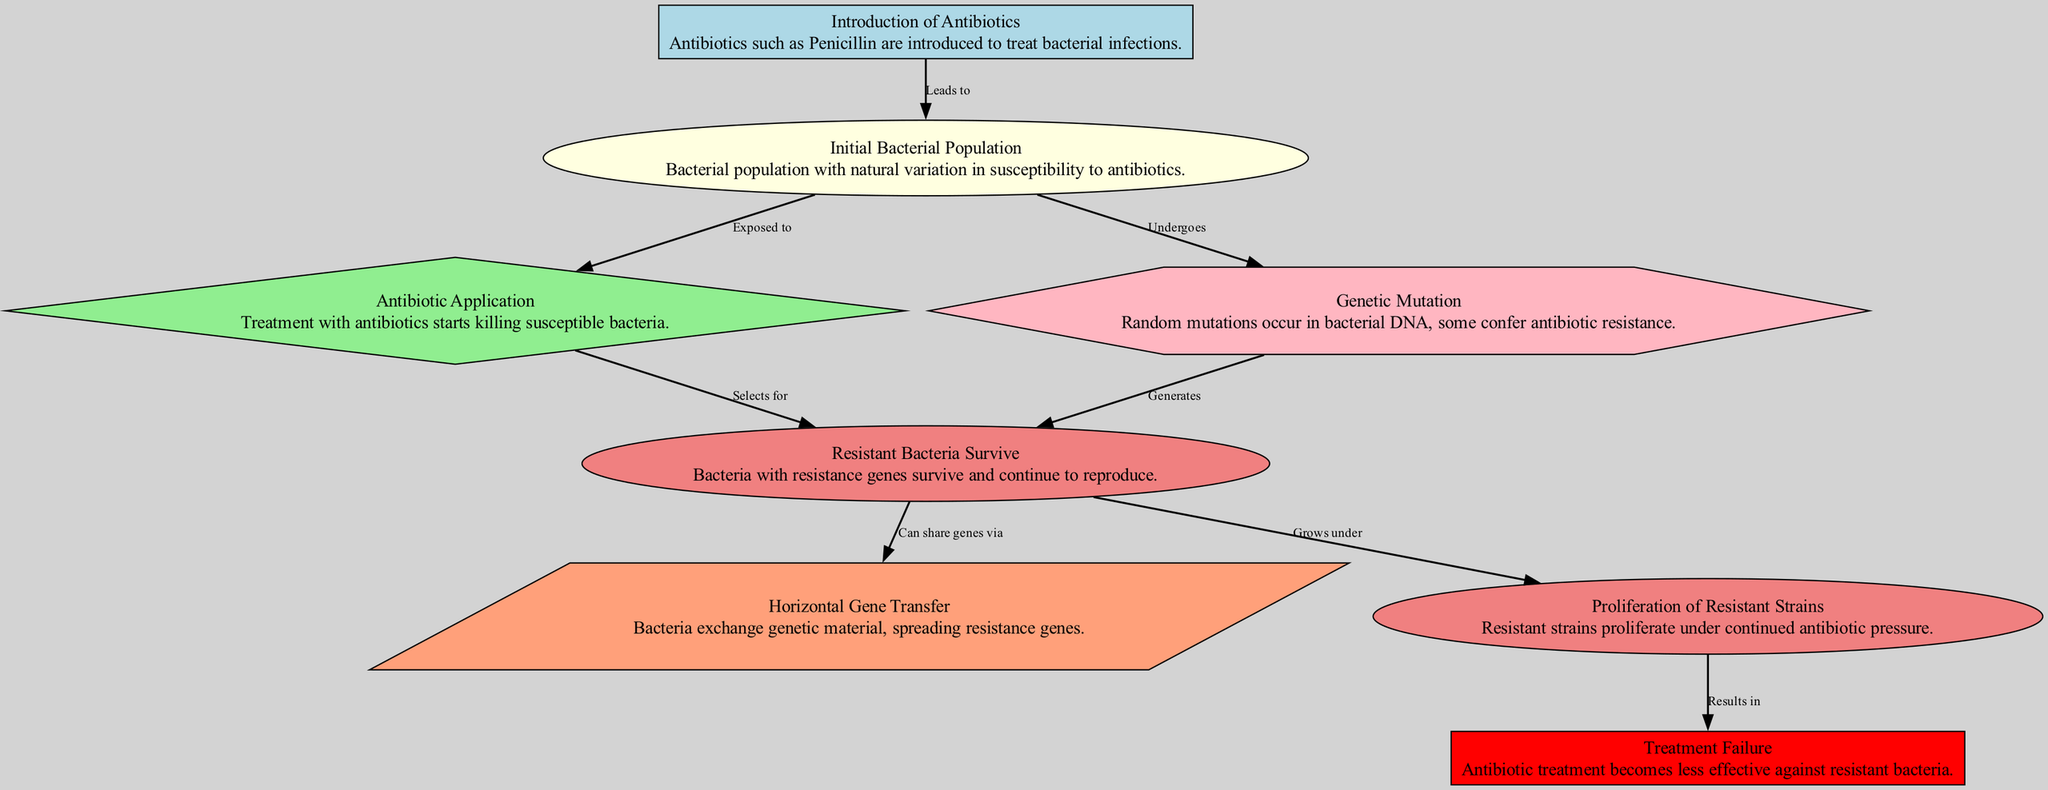What is the first node in the diagram? The first node listed is "Introduction of Antibiotics," which indicates the initial event in the evolution of antibiotic resistance.
Answer: Introduction of Antibiotics How many nodes are in the diagram? By counting the individual nodes, there are a total of eight nodes shown in the diagram representing different stages in the process.
Answer: 8 What label corresponds to node number four? Node number four is labeled "Resistant Bacteria Survive," which describes one of the key events after antibiotic application.
Answer: Resistant Bacteria Survive What relationship exists between nodes three and four? The relationship is labeled "Selects for," indicating that the application of antibiotics is selective for resistant bacteria, allowing them to survive.
Answer: Selects for What leads to the proliferation of resistant strains? The node labeled "Resistant Bacteria Survive" under continued antibiotic pressure is what leads to the proliferation of resistant strains.
Answer: Grows under How do bacteria acquire antibiotic resistance genes? Bacteria can exchange genetic material through Horizontal Gene Transfer, allowing the spread of resistance genes among bacterial populations.
Answer: Horizontal Gene Transfer What is the consequence of resistant strains proliferating? The proliferation of resistant strains results in Treatment Failure, making antibiotic treatments less effective over time.
Answer: Treatment Failure How do initial bacterial populations contribute to resistance? Initial bacterial populations are naturally varied in susceptibility, which allows some bacteria to survive the antibiotic application due to resistance genes.
Answer: Undergoes What generates resistant bacteria? Random mutations in bacterial DNA can generate antibiotic resistance among some bacteria in the population.
Answer: Generates 